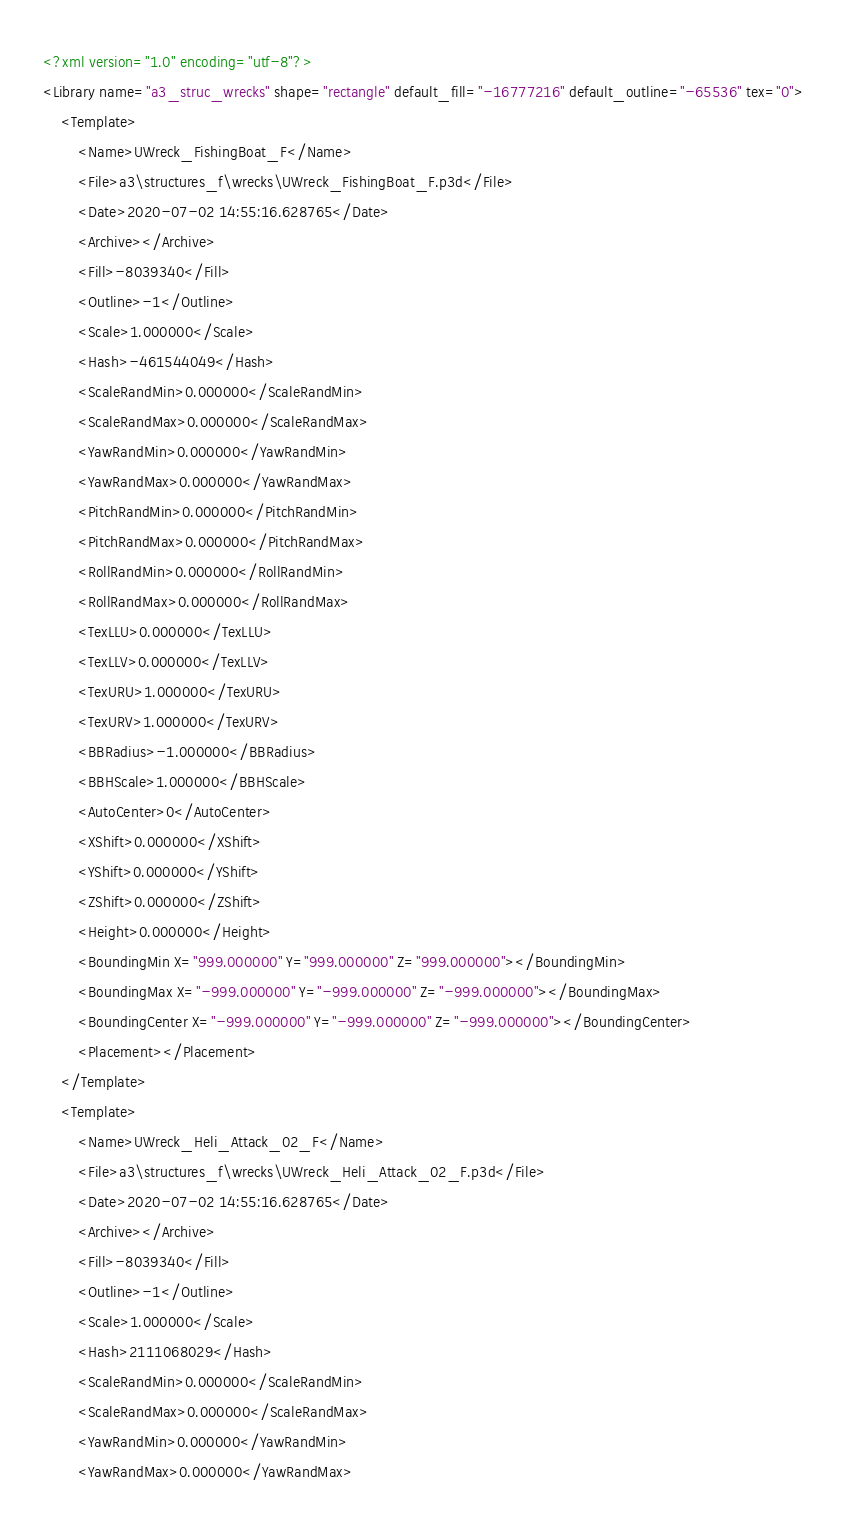<code> <loc_0><loc_0><loc_500><loc_500><_XML_><?xml version="1.0" encoding="utf-8"?>
<Library name="a3_struc_wrecks" shape="rectangle" default_fill="-16777216" default_outline="-65536" tex="0">
	<Template>
		<Name>UWreck_FishingBoat_F</Name>
		<File>a3\structures_f\wrecks\UWreck_FishingBoat_F.p3d</File>
		<Date>2020-07-02 14:55:16.628765</Date>
		<Archive></Archive>
		<Fill>-8039340</Fill>
		<Outline>-1</Outline>
		<Scale>1.000000</Scale>
		<Hash>-461544049</Hash>
		<ScaleRandMin>0.000000</ScaleRandMin>
		<ScaleRandMax>0.000000</ScaleRandMax>
		<YawRandMin>0.000000</YawRandMin>
		<YawRandMax>0.000000</YawRandMax>
		<PitchRandMin>0.000000</PitchRandMin>
		<PitchRandMax>0.000000</PitchRandMax>
		<RollRandMin>0.000000</RollRandMin>
		<RollRandMax>0.000000</RollRandMax>
		<TexLLU>0.000000</TexLLU>
		<TexLLV>0.000000</TexLLV>
		<TexURU>1.000000</TexURU>
		<TexURV>1.000000</TexURV>
		<BBRadius>-1.000000</BBRadius>
		<BBHScale>1.000000</BBHScale>
		<AutoCenter>0</AutoCenter>
		<XShift>0.000000</XShift>
		<YShift>0.000000</YShift>
		<ZShift>0.000000</ZShift>
		<Height>0.000000</Height>
		<BoundingMin X="999.000000" Y="999.000000" Z="999.000000"></BoundingMin>
		<BoundingMax X="-999.000000" Y="-999.000000" Z="-999.000000"></BoundingMax>
		<BoundingCenter X="-999.000000" Y="-999.000000" Z="-999.000000"></BoundingCenter>
		<Placement></Placement>
	</Template>
	<Template>
		<Name>UWreck_Heli_Attack_02_F</Name>
		<File>a3\structures_f\wrecks\UWreck_Heli_Attack_02_F.p3d</File>
		<Date>2020-07-02 14:55:16.628765</Date>
		<Archive></Archive>
		<Fill>-8039340</Fill>
		<Outline>-1</Outline>
		<Scale>1.000000</Scale>
		<Hash>2111068029</Hash>
		<ScaleRandMin>0.000000</ScaleRandMin>
		<ScaleRandMax>0.000000</ScaleRandMax>
		<YawRandMin>0.000000</YawRandMin>
		<YawRandMax>0.000000</YawRandMax></code> 